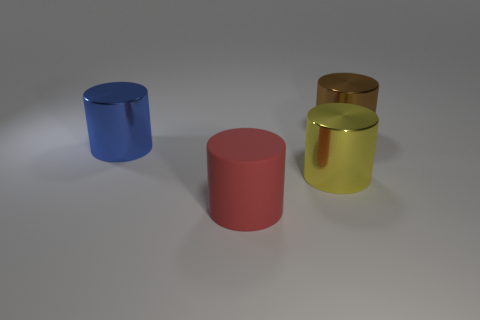Subtract all large blue metallic cylinders. How many cylinders are left? 3 Add 4 rubber cylinders. How many objects exist? 8 Subtract all yellow cylinders. How many cylinders are left? 3 Subtract 4 cylinders. How many cylinders are left? 0 Subtract all red cylinders. Subtract all green balls. How many cylinders are left? 3 Subtract all big red rubber spheres. Subtract all big brown metallic things. How many objects are left? 3 Add 4 brown objects. How many brown objects are left? 5 Add 3 large red things. How many large red things exist? 4 Subtract 1 brown cylinders. How many objects are left? 3 